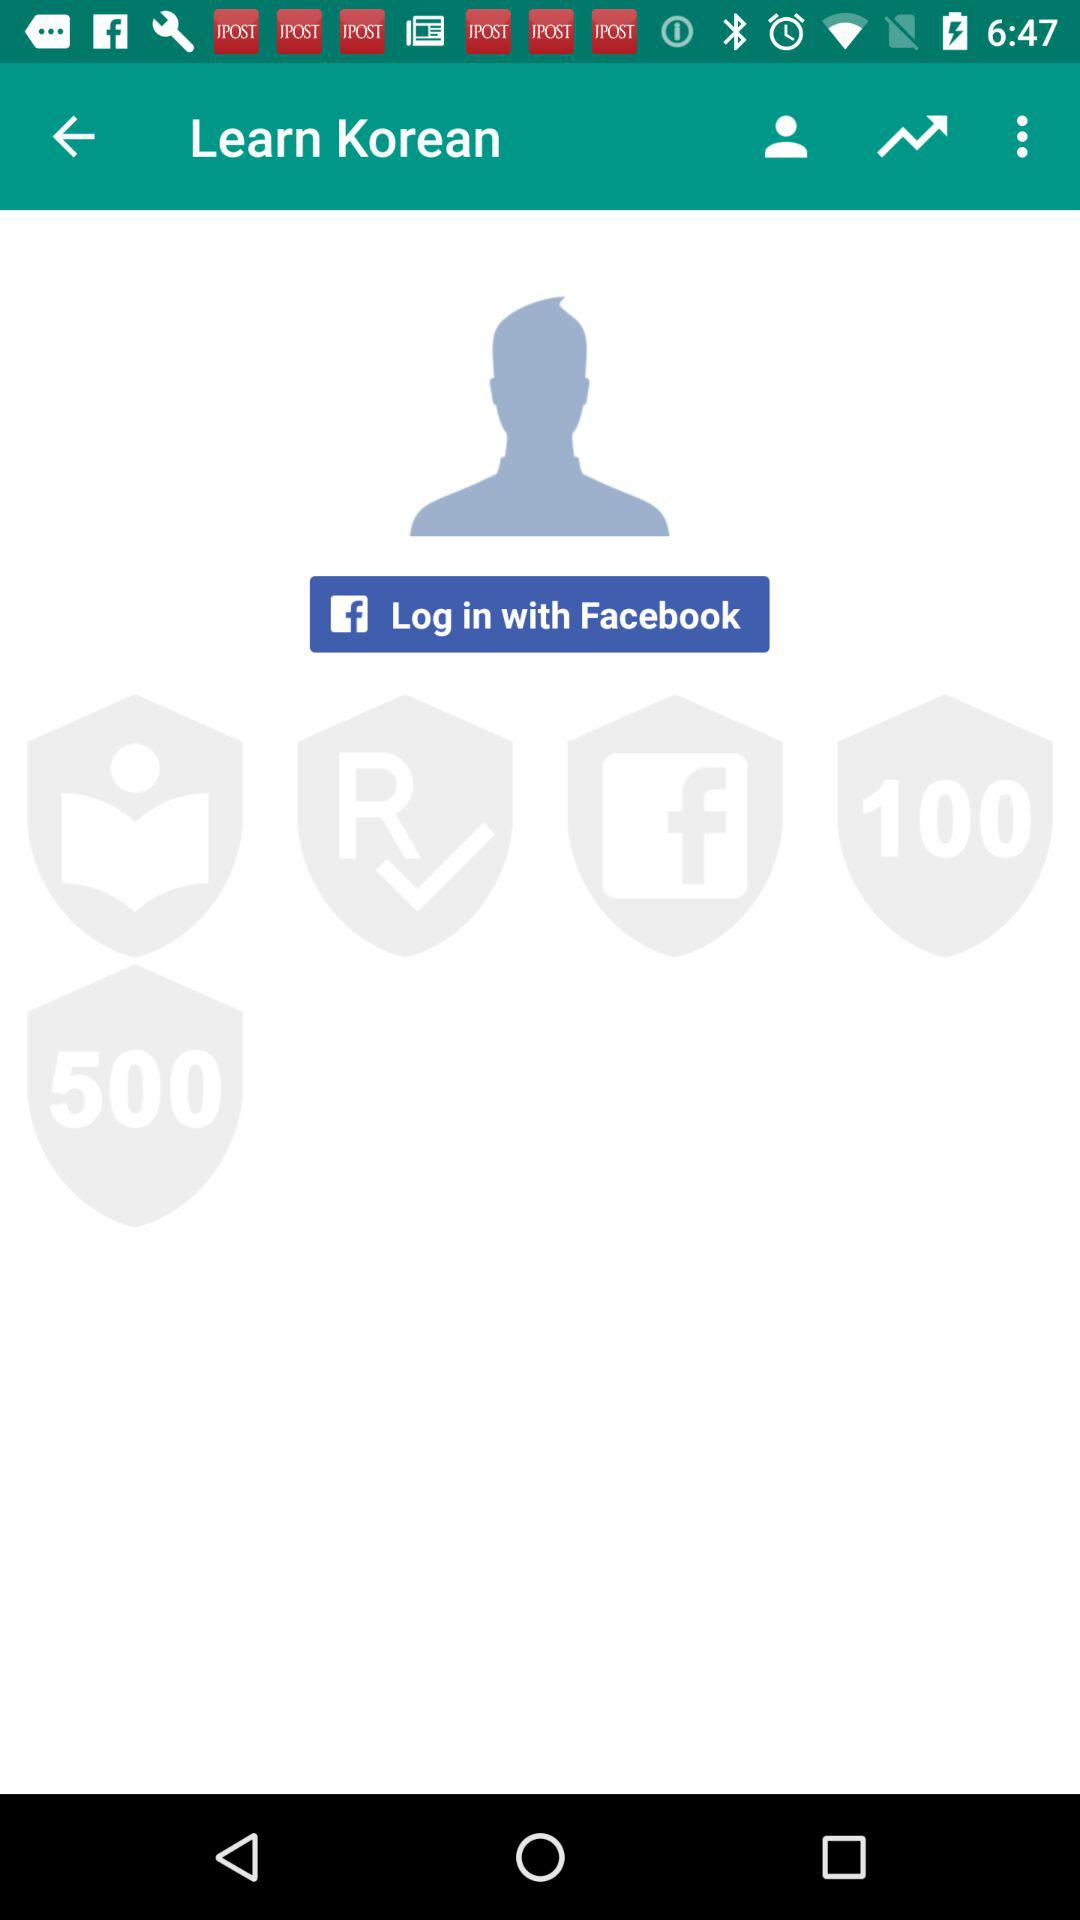What social media can we use for logging in? You can use "Facebook" for logging in. 